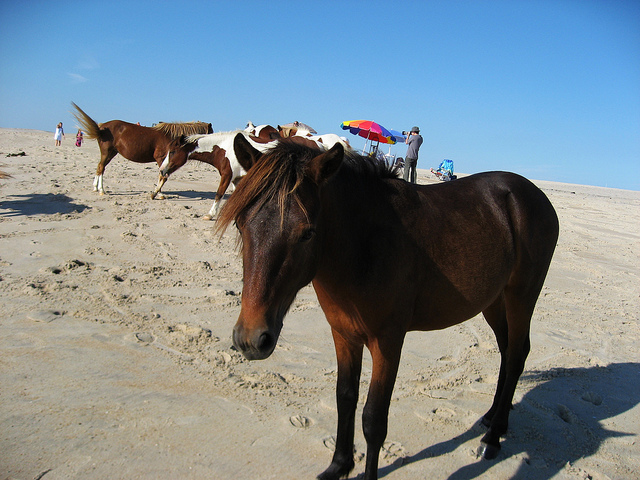Describe the physical characteristics of the horses in the image. The horses in the image exhibit a variety of coat colors, including rich browns and a white with brown patches. Most have long, flowing manes and tails, which may indicate that they are not groomed regularly, supporting the notion that they are wild or semi-wild. The muscle definition visible in their legs and the sheen on their coats suggests they are well-fed and healthy. Overall, they present a natural, untamed appearance, in contrast to the well-kept look of domesticated horses. 